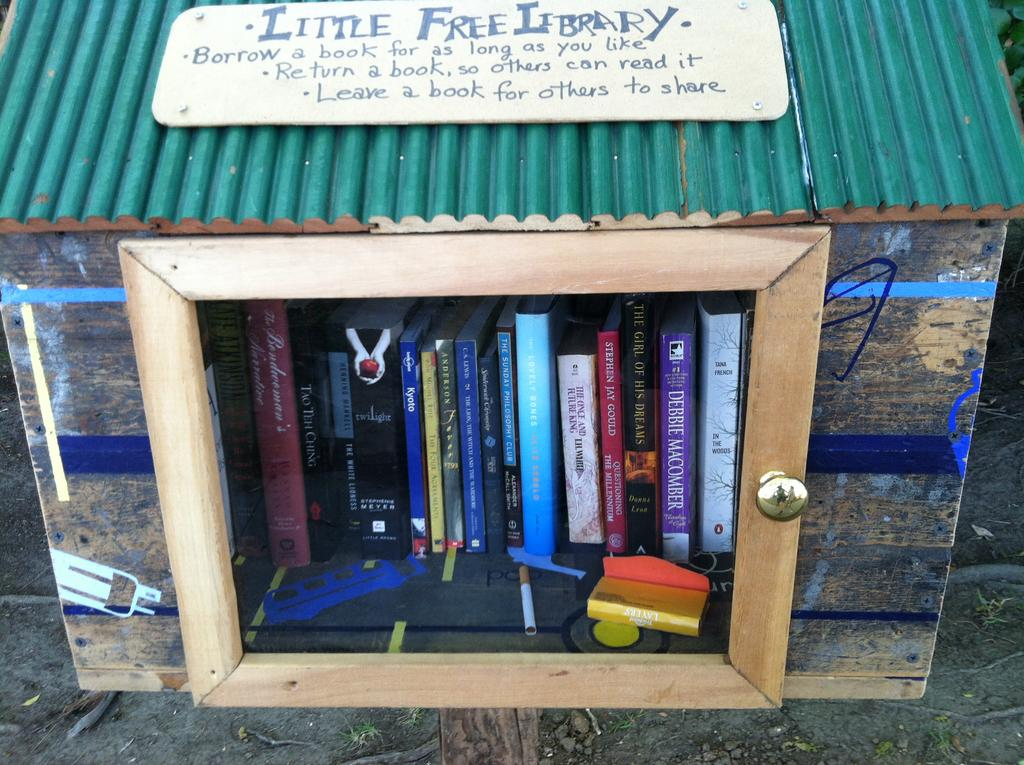<image>
Describe the image concisely. A wooden box with a glass door that is full of free books for the community to borrow. 